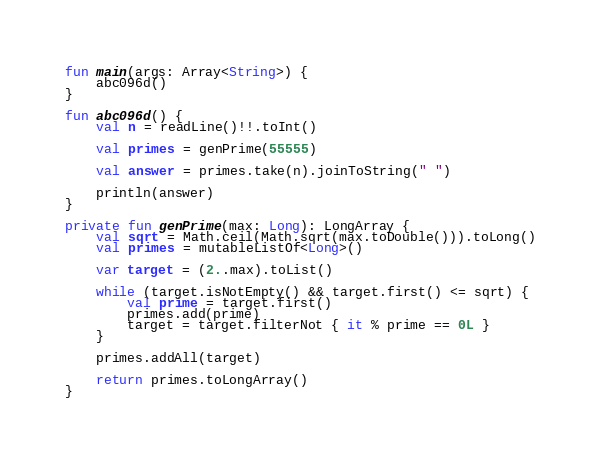<code> <loc_0><loc_0><loc_500><loc_500><_Kotlin_>fun main(args: Array<String>) {
    abc096d()
}

fun abc096d() {
    val n = readLine()!!.toInt()

    val primes = genPrime(55555)

    val answer = primes.take(n).joinToString(" ")

    println(answer)
}

private fun genPrime(max: Long): LongArray {
    val sqrt = Math.ceil(Math.sqrt(max.toDouble())).toLong()
    val primes = mutableListOf<Long>()

    var target = (2..max).toList()

    while (target.isNotEmpty() && target.first() <= sqrt) {
        val prime = target.first()
        primes.add(prime)
        target = target.filterNot { it % prime == 0L }
    }

    primes.addAll(target)

    return primes.toLongArray()
}
</code> 